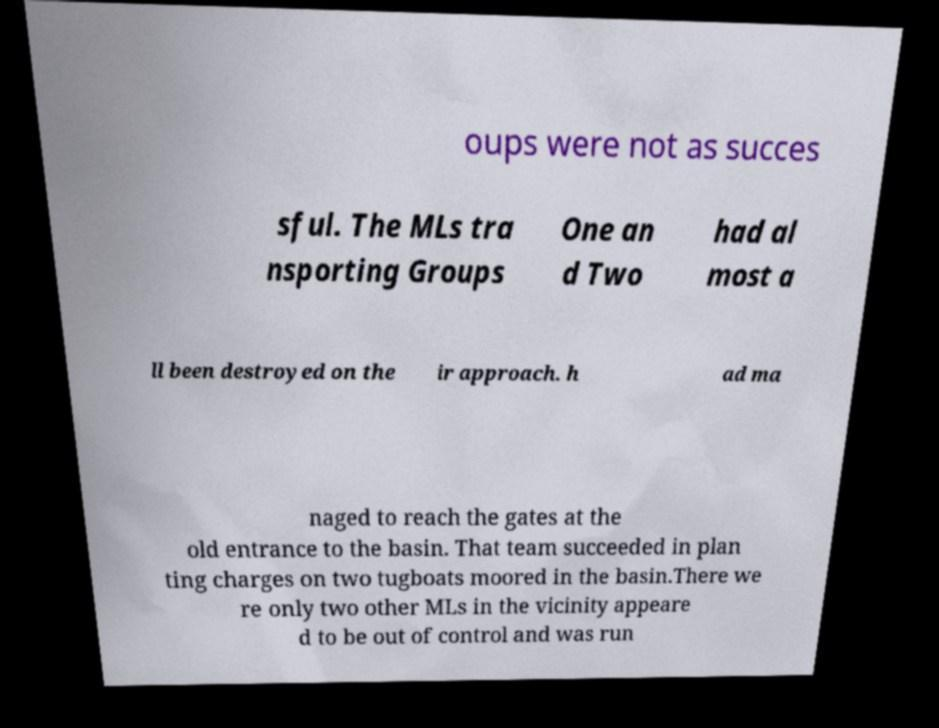There's text embedded in this image that I need extracted. Can you transcribe it verbatim? oups were not as succes sful. The MLs tra nsporting Groups One an d Two had al most a ll been destroyed on the ir approach. h ad ma naged to reach the gates at the old entrance to the basin. That team succeeded in plan ting charges on two tugboats moored in the basin.There we re only two other MLs in the vicinity appeare d to be out of control and was run 